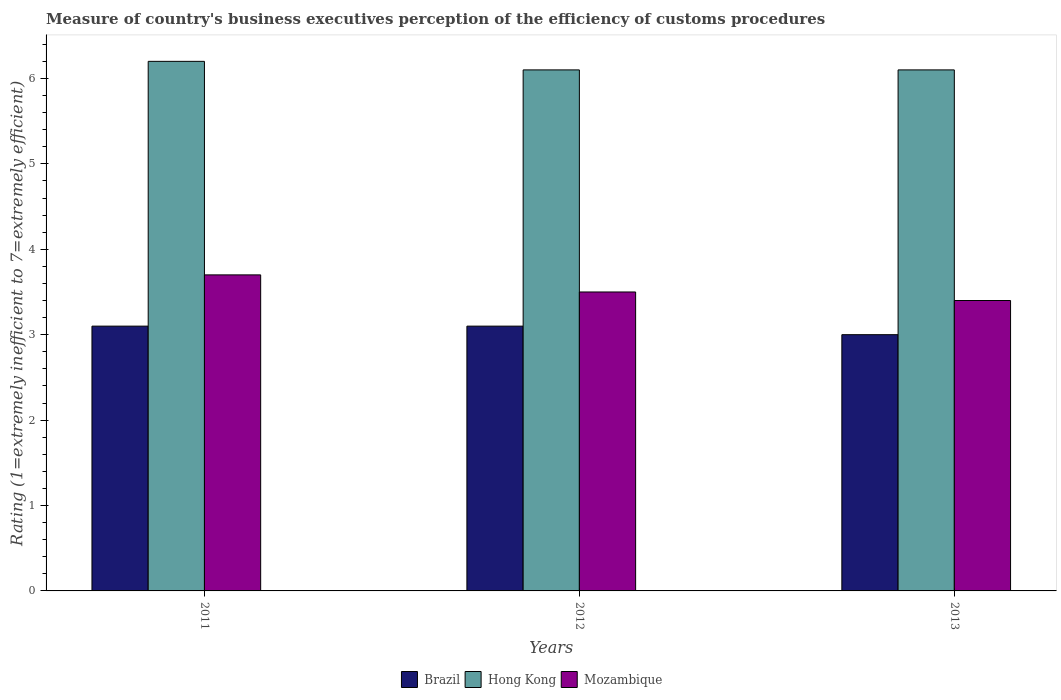How many different coloured bars are there?
Give a very brief answer. 3. Across all years, what is the maximum rating of the efficiency of customs procedure in Mozambique?
Offer a very short reply. 3.7. Across all years, what is the minimum rating of the efficiency of customs procedure in Brazil?
Offer a terse response. 3. In which year was the rating of the efficiency of customs procedure in Mozambique maximum?
Ensure brevity in your answer.  2011. What is the difference between the rating of the efficiency of customs procedure in Mozambique in 2011 and that in 2013?
Make the answer very short. 0.3. What is the difference between the rating of the efficiency of customs procedure in Mozambique in 2011 and the rating of the efficiency of customs procedure in Brazil in 2013?
Give a very brief answer. 0.7. What is the average rating of the efficiency of customs procedure in Hong Kong per year?
Provide a short and direct response. 6.13. In the year 2013, what is the difference between the rating of the efficiency of customs procedure in Mozambique and rating of the efficiency of customs procedure in Brazil?
Your answer should be compact. 0.4. In how many years, is the rating of the efficiency of customs procedure in Brazil greater than 2.8?
Provide a succinct answer. 3. What is the ratio of the rating of the efficiency of customs procedure in Mozambique in 2011 to that in 2012?
Provide a succinct answer. 1.06. Is the difference between the rating of the efficiency of customs procedure in Mozambique in 2011 and 2012 greater than the difference between the rating of the efficiency of customs procedure in Brazil in 2011 and 2012?
Provide a succinct answer. Yes. What is the difference between the highest and the second highest rating of the efficiency of customs procedure in Mozambique?
Your response must be concise. 0.2. What is the difference between the highest and the lowest rating of the efficiency of customs procedure in Hong Kong?
Offer a very short reply. 0.1. Is the sum of the rating of the efficiency of customs procedure in Mozambique in 2011 and 2013 greater than the maximum rating of the efficiency of customs procedure in Hong Kong across all years?
Make the answer very short. Yes. What does the 2nd bar from the left in 2012 represents?
Your answer should be very brief. Hong Kong. What does the 2nd bar from the right in 2012 represents?
Ensure brevity in your answer.  Hong Kong. How many bars are there?
Offer a very short reply. 9. Are all the bars in the graph horizontal?
Give a very brief answer. No. How many years are there in the graph?
Make the answer very short. 3. What is the difference between two consecutive major ticks on the Y-axis?
Offer a terse response. 1. Are the values on the major ticks of Y-axis written in scientific E-notation?
Give a very brief answer. No. Does the graph contain grids?
Give a very brief answer. No. Where does the legend appear in the graph?
Your answer should be very brief. Bottom center. What is the title of the graph?
Provide a short and direct response. Measure of country's business executives perception of the efficiency of customs procedures. Does "United Kingdom" appear as one of the legend labels in the graph?
Offer a very short reply. No. What is the label or title of the Y-axis?
Offer a very short reply. Rating (1=extremely inefficient to 7=extremely efficient). What is the Rating (1=extremely inefficient to 7=extremely efficient) of Hong Kong in 2011?
Offer a very short reply. 6.2. What is the Rating (1=extremely inefficient to 7=extremely efficient) of Mozambique in 2011?
Offer a very short reply. 3.7. What is the Rating (1=extremely inefficient to 7=extremely efficient) in Hong Kong in 2012?
Offer a very short reply. 6.1. What is the Rating (1=extremely inefficient to 7=extremely efficient) of Mozambique in 2012?
Offer a terse response. 3.5. What is the Rating (1=extremely inefficient to 7=extremely efficient) in Brazil in 2013?
Provide a short and direct response. 3. What is the Rating (1=extremely inefficient to 7=extremely efficient) in Hong Kong in 2013?
Make the answer very short. 6.1. Across all years, what is the maximum Rating (1=extremely inefficient to 7=extremely efficient) in Brazil?
Provide a succinct answer. 3.1. Across all years, what is the maximum Rating (1=extremely inefficient to 7=extremely efficient) of Mozambique?
Keep it short and to the point. 3.7. Across all years, what is the minimum Rating (1=extremely inefficient to 7=extremely efficient) of Hong Kong?
Keep it short and to the point. 6.1. What is the total Rating (1=extremely inefficient to 7=extremely efficient) of Brazil in the graph?
Make the answer very short. 9.2. What is the difference between the Rating (1=extremely inefficient to 7=extremely efficient) of Brazil in 2011 and that in 2013?
Keep it short and to the point. 0.1. What is the difference between the Rating (1=extremely inefficient to 7=extremely efficient) in Hong Kong in 2011 and that in 2013?
Offer a very short reply. 0.1. What is the difference between the Rating (1=extremely inefficient to 7=extremely efficient) of Brazil in 2011 and the Rating (1=extremely inefficient to 7=extremely efficient) of Hong Kong in 2012?
Provide a succinct answer. -3. What is the difference between the Rating (1=extremely inefficient to 7=extremely efficient) in Hong Kong in 2011 and the Rating (1=extremely inefficient to 7=extremely efficient) in Mozambique in 2012?
Provide a short and direct response. 2.7. What is the difference between the Rating (1=extremely inefficient to 7=extremely efficient) in Brazil in 2011 and the Rating (1=extremely inefficient to 7=extremely efficient) in Hong Kong in 2013?
Your answer should be very brief. -3. What is the difference between the Rating (1=extremely inefficient to 7=extremely efficient) in Brazil in 2011 and the Rating (1=extremely inefficient to 7=extremely efficient) in Mozambique in 2013?
Offer a terse response. -0.3. What is the difference between the Rating (1=extremely inefficient to 7=extremely efficient) of Brazil in 2012 and the Rating (1=extremely inefficient to 7=extremely efficient) of Hong Kong in 2013?
Give a very brief answer. -3. What is the difference between the Rating (1=extremely inefficient to 7=extremely efficient) of Brazil in 2012 and the Rating (1=extremely inefficient to 7=extremely efficient) of Mozambique in 2013?
Make the answer very short. -0.3. What is the average Rating (1=extremely inefficient to 7=extremely efficient) in Brazil per year?
Your response must be concise. 3.07. What is the average Rating (1=extremely inefficient to 7=extremely efficient) of Hong Kong per year?
Offer a very short reply. 6.13. What is the average Rating (1=extremely inefficient to 7=extremely efficient) in Mozambique per year?
Keep it short and to the point. 3.53. In the year 2013, what is the difference between the Rating (1=extremely inefficient to 7=extremely efficient) of Brazil and Rating (1=extremely inefficient to 7=extremely efficient) of Hong Kong?
Your answer should be compact. -3.1. What is the ratio of the Rating (1=extremely inefficient to 7=extremely efficient) in Hong Kong in 2011 to that in 2012?
Ensure brevity in your answer.  1.02. What is the ratio of the Rating (1=extremely inefficient to 7=extremely efficient) of Mozambique in 2011 to that in 2012?
Offer a very short reply. 1.06. What is the ratio of the Rating (1=extremely inefficient to 7=extremely efficient) of Brazil in 2011 to that in 2013?
Keep it short and to the point. 1.03. What is the ratio of the Rating (1=extremely inefficient to 7=extremely efficient) in Hong Kong in 2011 to that in 2013?
Your answer should be very brief. 1.02. What is the ratio of the Rating (1=extremely inefficient to 7=extremely efficient) of Mozambique in 2011 to that in 2013?
Your response must be concise. 1.09. What is the ratio of the Rating (1=extremely inefficient to 7=extremely efficient) in Hong Kong in 2012 to that in 2013?
Your response must be concise. 1. What is the ratio of the Rating (1=extremely inefficient to 7=extremely efficient) of Mozambique in 2012 to that in 2013?
Your response must be concise. 1.03. What is the difference between the highest and the second highest Rating (1=extremely inefficient to 7=extremely efficient) of Brazil?
Keep it short and to the point. 0. What is the difference between the highest and the second highest Rating (1=extremely inefficient to 7=extremely efficient) of Hong Kong?
Your response must be concise. 0.1. What is the difference between the highest and the lowest Rating (1=extremely inefficient to 7=extremely efficient) in Brazil?
Keep it short and to the point. 0.1. What is the difference between the highest and the lowest Rating (1=extremely inefficient to 7=extremely efficient) of Hong Kong?
Offer a terse response. 0.1. 